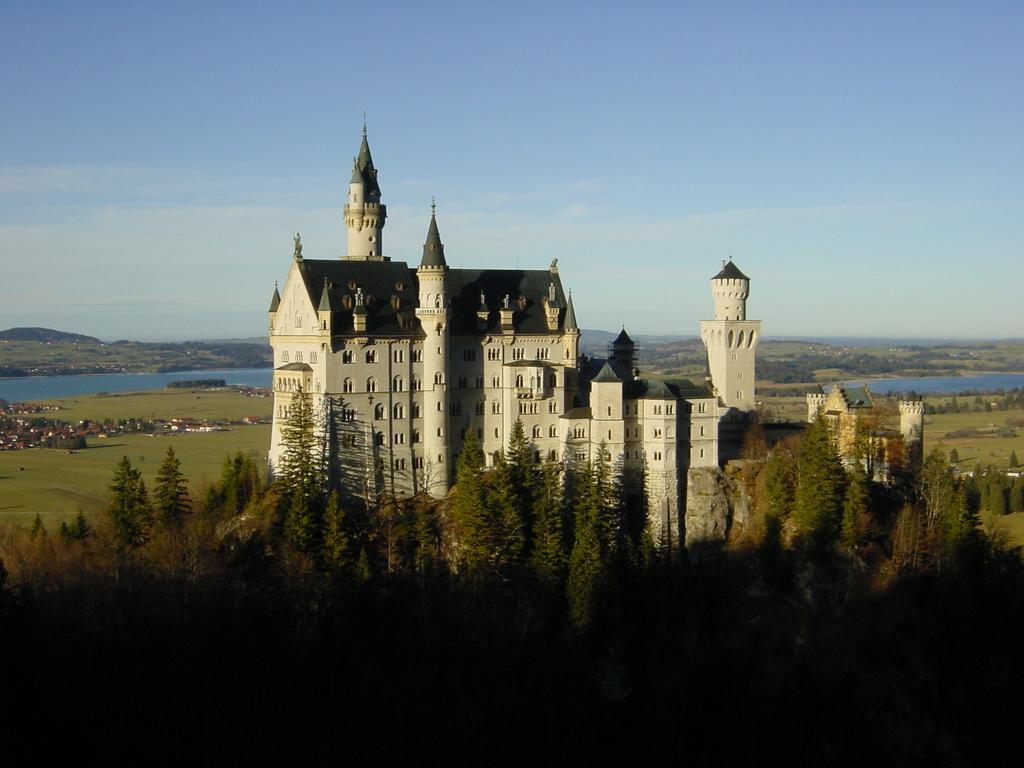Describe this image in one or two sentences. In this image I can see a building in white color. I can also see few trees in green color, background I can see water, and sky in blue and white color. 